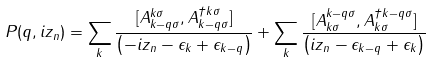<formula> <loc_0><loc_0><loc_500><loc_500>P ( { q } , i z _ { n } ) = \sum _ { k } \frac { [ A _ { { k } - { q } \sigma } ^ { k \sigma } , A _ { { k } - { q } \sigma } ^ { \dagger { k } \sigma } ] } { \left ( - i z _ { n } - \epsilon _ { k } + \epsilon _ { { k } - { q } } \right ) } + \sum _ { k } \frac { [ A _ { { k } \sigma } ^ { { k } - { q } \sigma } , A _ { { k } \sigma } ^ { \dagger { k } - { q } \sigma } ] } { \left ( i z _ { n } - \epsilon _ { { k } - { q } } + \epsilon _ { k } \right ) }</formula> 